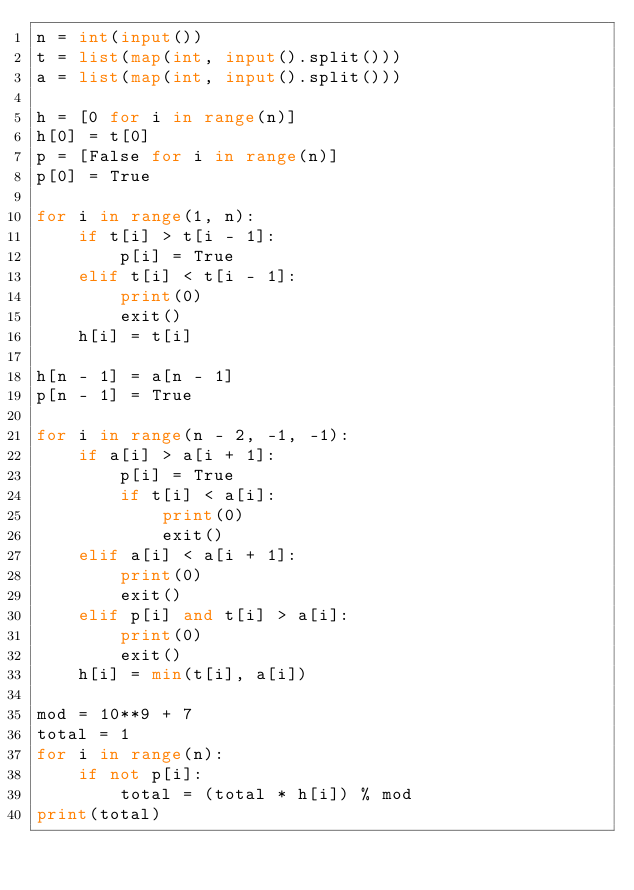Convert code to text. <code><loc_0><loc_0><loc_500><loc_500><_Python_>n = int(input())
t = list(map(int, input().split()))
a = list(map(int, input().split()))

h = [0 for i in range(n)]
h[0] = t[0]
p = [False for i in range(n)]
p[0] = True

for i in range(1, n):
    if t[i] > t[i - 1]:
        p[i] = True
    elif t[i] < t[i - 1]:
        print(0)
        exit()
    h[i] = t[i]

h[n - 1] = a[n - 1]
p[n - 1] = True

for i in range(n - 2, -1, -1):
    if a[i] > a[i + 1]:
        p[i] = True
        if t[i] < a[i]:
            print(0)
            exit()
    elif a[i] < a[i + 1]:
        print(0)
        exit()
    elif p[i] and t[i] > a[i]:
        print(0)
        exit()
    h[i] = min(t[i], a[i])

mod = 10**9 + 7
total = 1
for i in range(n):
    if not p[i]:
        total = (total * h[i]) % mod
print(total)
 </code> 